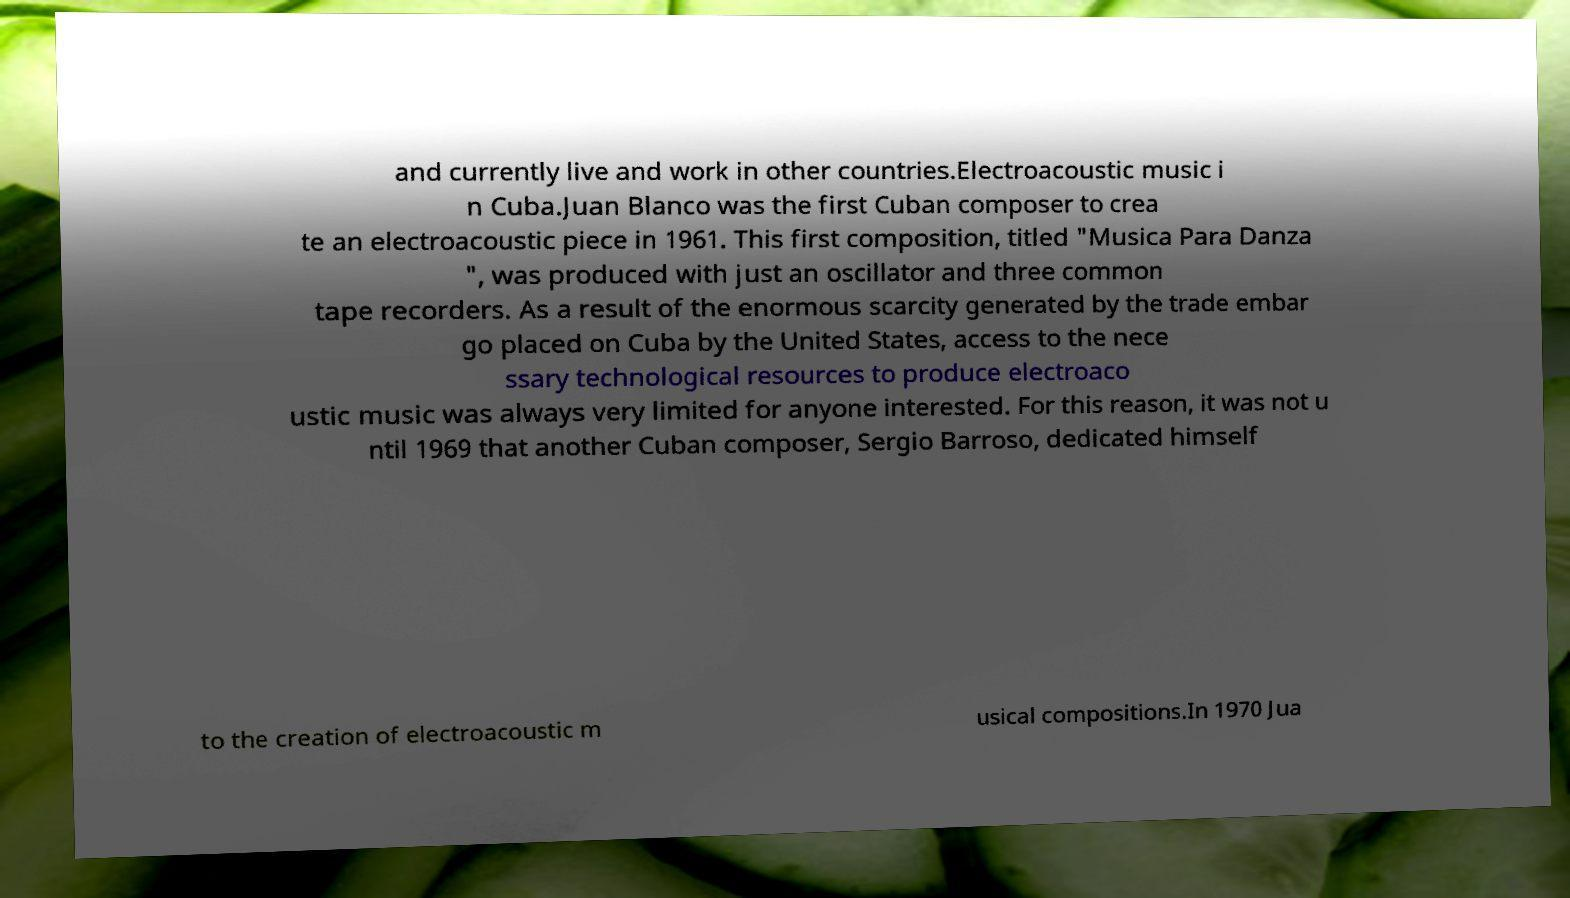I need the written content from this picture converted into text. Can you do that? and currently live and work in other countries.Electroacoustic music i n Cuba.Juan Blanco was the first Cuban composer to crea te an electroacoustic piece in 1961. This first composition, titled "Musica Para Danza ", was produced with just an oscillator and three common tape recorders. As a result of the enormous scarcity generated by the trade embar go placed on Cuba by the United States, access to the nece ssary technological resources to produce electroaco ustic music was always very limited for anyone interested. For this reason, it was not u ntil 1969 that another Cuban composer, Sergio Barroso, dedicated himself to the creation of electroacoustic m usical compositions.In 1970 Jua 